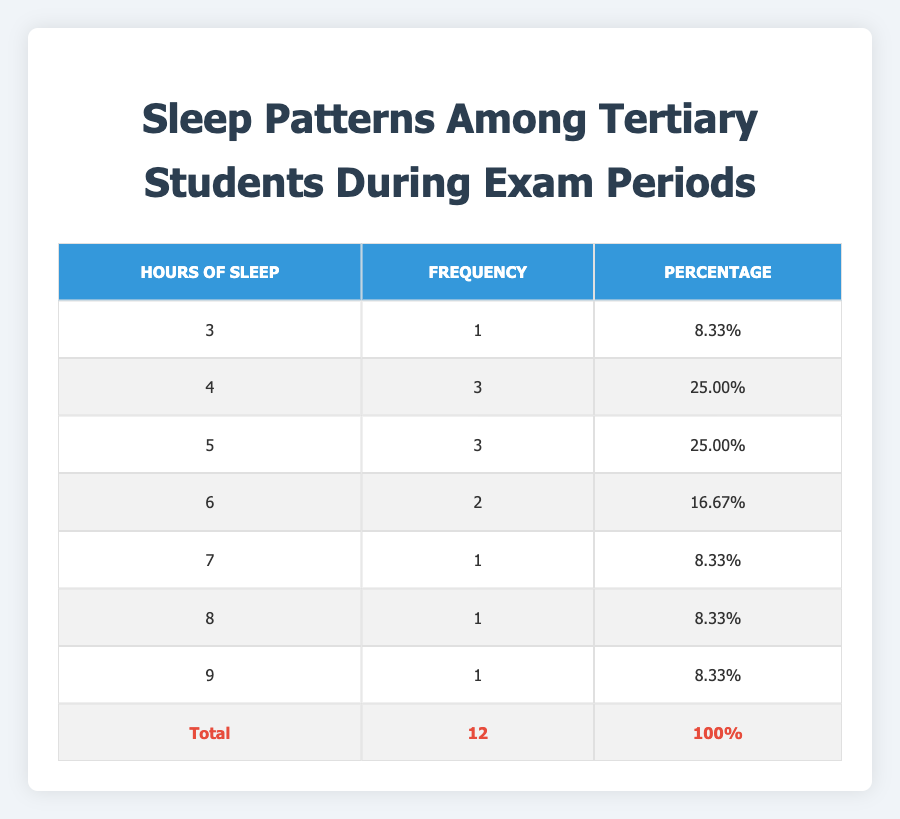What is the highest number of hours of sleep recorded in the table? The table shows the different hours of sleep recorded, and the maximum value is 9 hours, as indicated in the row.
Answer: 9 How many students reported sleeping for 4 hours? The table directly lists the frequency of students sleeping for each hour count, showing that 3 students reported sleeping for 4 hours.
Answer: 3 What is the total number of hours of sleep reported by students? To find the total hours of sleep, we multiply each hours value by its corresponding frequency and then sum them. That is (3*1) + (4*3) + (5*3) + (6*2) + (7*1) + (8*1) + (9*1) = 3 + 12 + 15 + 12 + 7 + 8 + 9 = 66.
Answer: 66 Is it true that no students slept for 2 hours? There is no entry in the table for students sleeping 2 hours, confirming that no students reported this amount of sleep.
Answer: Yes What percentage of students slept for 6 hours or more? First, count the number of students who slept for 6 hours or more: 8 (from hour counts of 6, 7, and 9). To calculate the percentage, divide this number by the total number of students (12), which gives 8/12 = 0.6667, or 66.67%.
Answer: 66.67% 